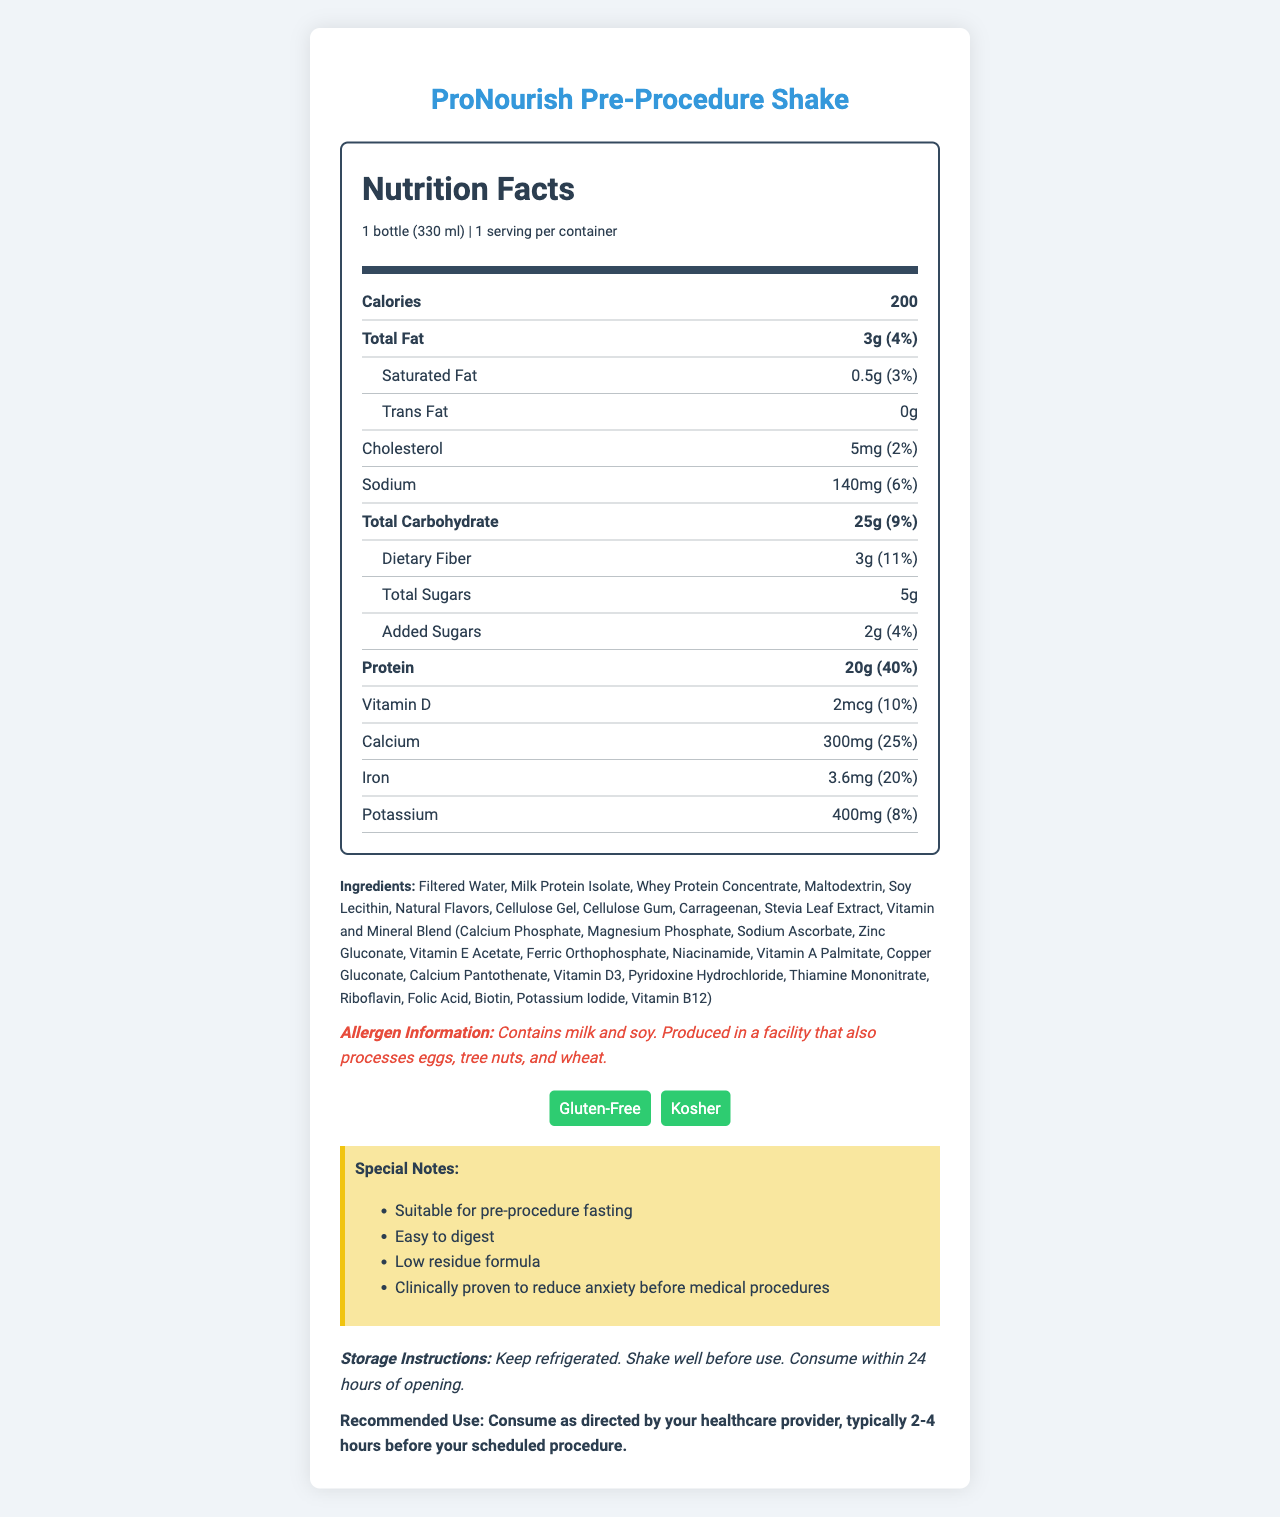what is the serving size for this shake? The serving size is clearly stated in the Nutrition Facts section as 1 bottle (330 ml).
Answer: 1 bottle (330 ml) how many calories are in one serving? The Nutrition Facts section lists the calories as 200.
Answer: 200 what percentage of the daily value of sodium does this shake provide? The amount of sodium is 140mg, which constitutes 6% of the daily value.
Answer: 6% what are the main allergens present in this product? The allergen information section lists milk and soy as the main allergens.
Answer: Milk and soy is this shake gluten-free? The certifications section includes a certification for "Gluten-Free."
Answer: Yes what special benefits does this shake provide for pre-procedure fasting? The special notes section highlights these benefits.
Answer: Suitable for pre-procedure fasting, easy to digest, low residue formula, clinically proven to reduce anxiety before medical procedures how should this shake be stored? The storage instructions section provides these details.
Answer: Keep refrigerated. Shake well before use. Consume within 24 hours of opening. When should you consume this shake before a medical procedure? The recommended use section advises consuming it 2-4 hours before the procedure.
Answer: 2-4 hours before the scheduled procedure How much protein does one serving of this shake provide? The protein content per serving is listed as 20g in the Nutrition Facts section.
Answer: 20g which of the following vitamins does this shake not contain?
I. Vitamin K
II. Vitamin C
III. Vitamin B12
IV. Vitamin A The listed vitamins in the Nutrition Facts section do not include Vitamin K.
Answer: I. Vitamin K What certifications does this shake have? A. Organic and Gluten-Free B. Kosher and Organic C. Kosher and Gluten-Free The certifications listed for the product are Kosher and Gluten-Free.
Answer: C. Kosher and Gluten-Free Does this shake contain any trans fat? The Nutrition Facts section lists the trans fat content as 0g.
Answer: No describe the main idea of the ProNourish Pre-Procedure Shake's nutrition label. The document is a detailed Nutrition Facts label for ProNourish Pre-Procedure Shake, providing information on serving size, nutritional content, allergens, and certifications along with special notes, storage instructions, and recommended use.
Answer: The ProNourish Pre-Procedure Shake is a high-protein meal replacement that is suitable for pre-procedure fasting, easy to digest, and has special benefits like reducing anxiety before medical procedures. It is low in calories, contains essential vitamins and minerals, and is free from gluten. The product should be consumed 2-4 hours before a procedure and stored in a refrigerator. What is the percentage of daily vitamin D provided by one serving of the shake? The Nutrition Facts section lists the vitamin D content as 2mcg, which is 10% of the daily value.
Answer: 10% What is the main protein source in this shake? The ingredients list "Milk Protein Isolate" as one of the main components.
Answer: Milk Protein Isolate How many servings are there per container? The serving info specifies that there is 1 serving per container.
Answer: 1 How much potassium does this shake contain per serving? The potassium content is listed as 400mg.
Answer: 400mg Can I consume this shake if I'm allergic to eggs? The allergen information states that it is produced in a facility that also processes eggs, but it does not definitively say if the product contains eggs directly.
Answer: Cannot be determined What is the daily value percentage for iron provided by one serving of the shake? The iron content is 3.6mg, which is 20% of the daily value.
Answer: 20% What should be done before consuming the shake to ensure proper use? The storage instructions include shaking the bottle well before use.
Answer: Shake well 